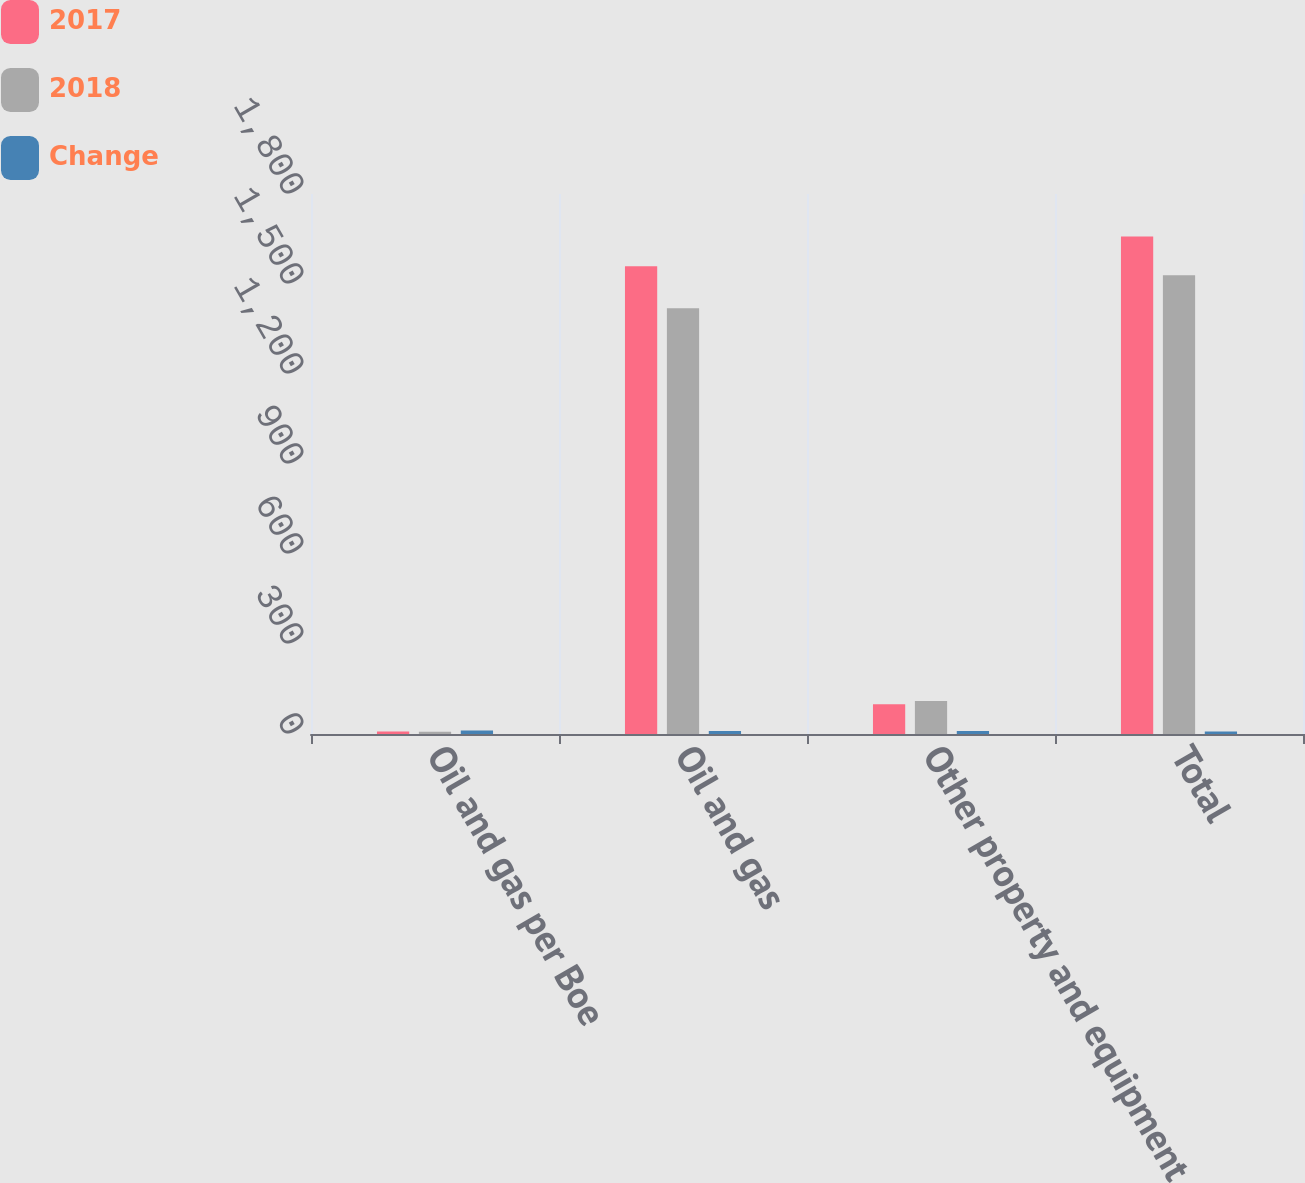Convert chart to OTSL. <chart><loc_0><loc_0><loc_500><loc_500><stacked_bar_chart><ecel><fcel>Oil and gas per Boe<fcel>Oil and gas<fcel>Other property and equipment<fcel>Total<nl><fcel>2017<fcel>7.98<fcel>1559<fcel>99<fcel>1658<nl><fcel>2018<fcel>7.15<fcel>1419<fcel>110<fcel>1529<nl><fcel>Change<fcel>12<fcel>10<fcel>10<fcel>8<nl></chart> 